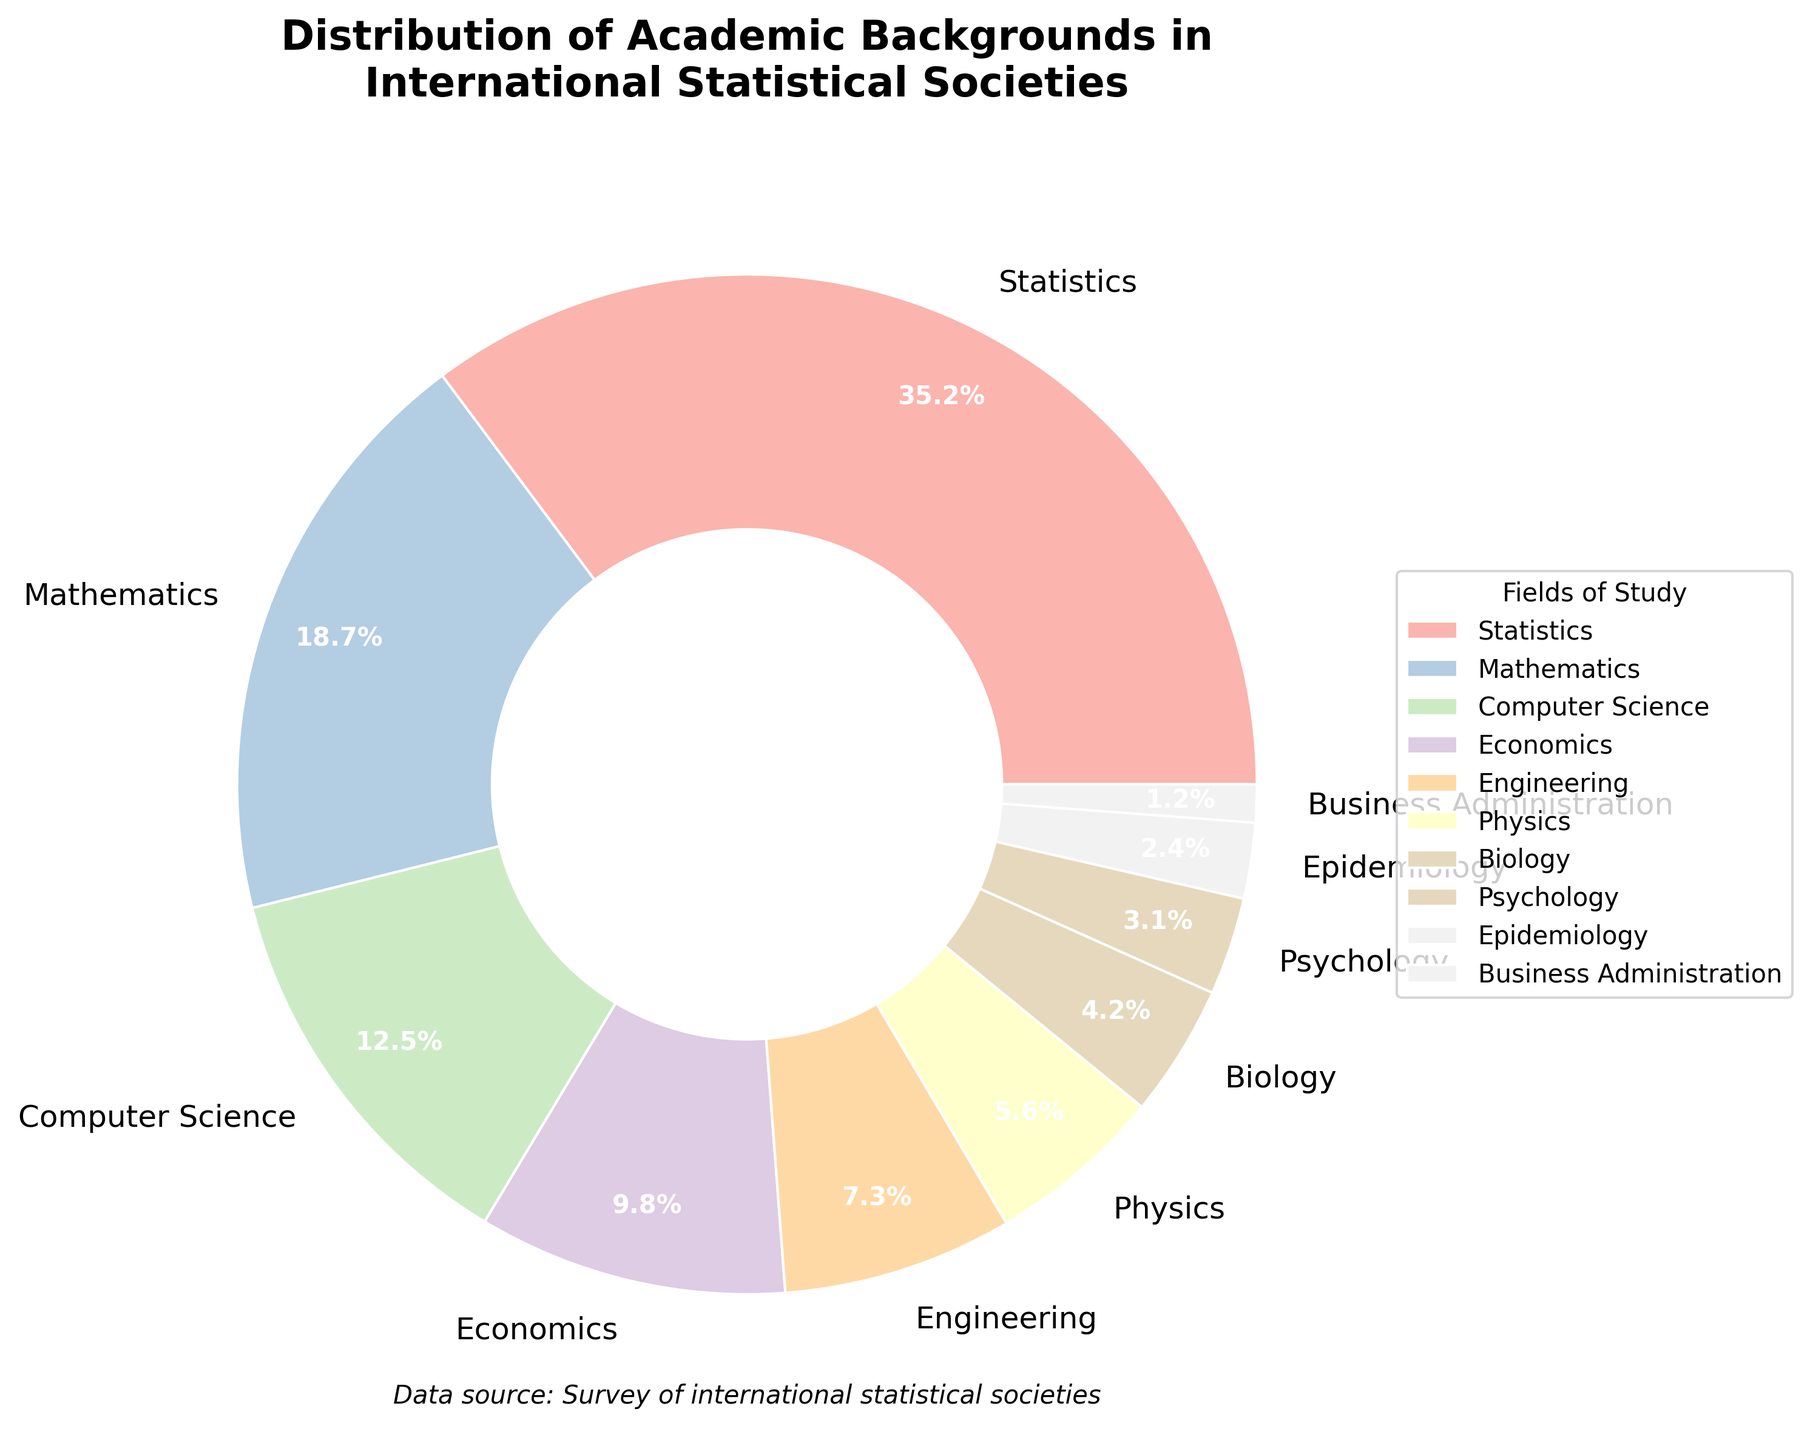Which field of study has the highest percentage representation in the pie chart? The field of study with the highest percentage is the one with the largest section of the pie chart. In this chart, the largest section is labeled "Statistics" with a percentage of 35.2%.
Answer: Statistics Which field has a higher percentage: Computer Science or Engineering? By comparing the sections labeled "Computer Science" and "Engineering" in the pie chart, we see that "Computer Science" has 12.5% and "Engineering" has 7.3%. Thus, "Computer Science" has a higher percentage.
Answer: Computer Science What is the combined percentage of Physics, Biology, and Psychology? The pie chart shows the percentages for Physics, Biology, and Psychology as 5.6%, 4.2%, and 3.1% respectively. Adding these together, 5.6 + 4.2 + 3.1 = 12.9%.
Answer: 12.9% How much more does Statistics represent compared to Economics? The percentage for Statistics is 35.2% and for Economics, it is 9.8%. Subtracting these, 35.2 - 9.8 = 25.4%.
Answer: 25.4% Which fields of study have percentages below 5% and what are their combined percentages? From the pie chart, the fields of study below 5% are Biology (4.2%), Psychology (3.1%), Epidemiology (2.4%), and Business Administration (1.2%). Summing these, 4.2 + 3.1 + 2.4 + 1.2 = 10.9%.
Answer: 10.9% What visual attribute makes the field with the lowest percentage easily identifiable? The field with the lowest percentage (1.2%) is Business Administration, which has the smallest section in the chart. This makes it easily identifiable by its small size compared to other sections.
Answer: Small size Which two fields together would have the combined percentage closest to 20%? By examining the chart for possible combinations: Physics (5.6%) + Engineering (7.3%) = 12.9%, Mathematics (18.7%) + Business Administration (1.2%) = 19.9%, and Computer Science (12.5%) + Psychology (3.1%) = 15.6%. Thus, Mathematics and Business Administration together come the closest at 19.9%.
Answer: Mathematics and Business Administration 